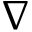<formula> <loc_0><loc_0><loc_500><loc_500>\nabla</formula> 